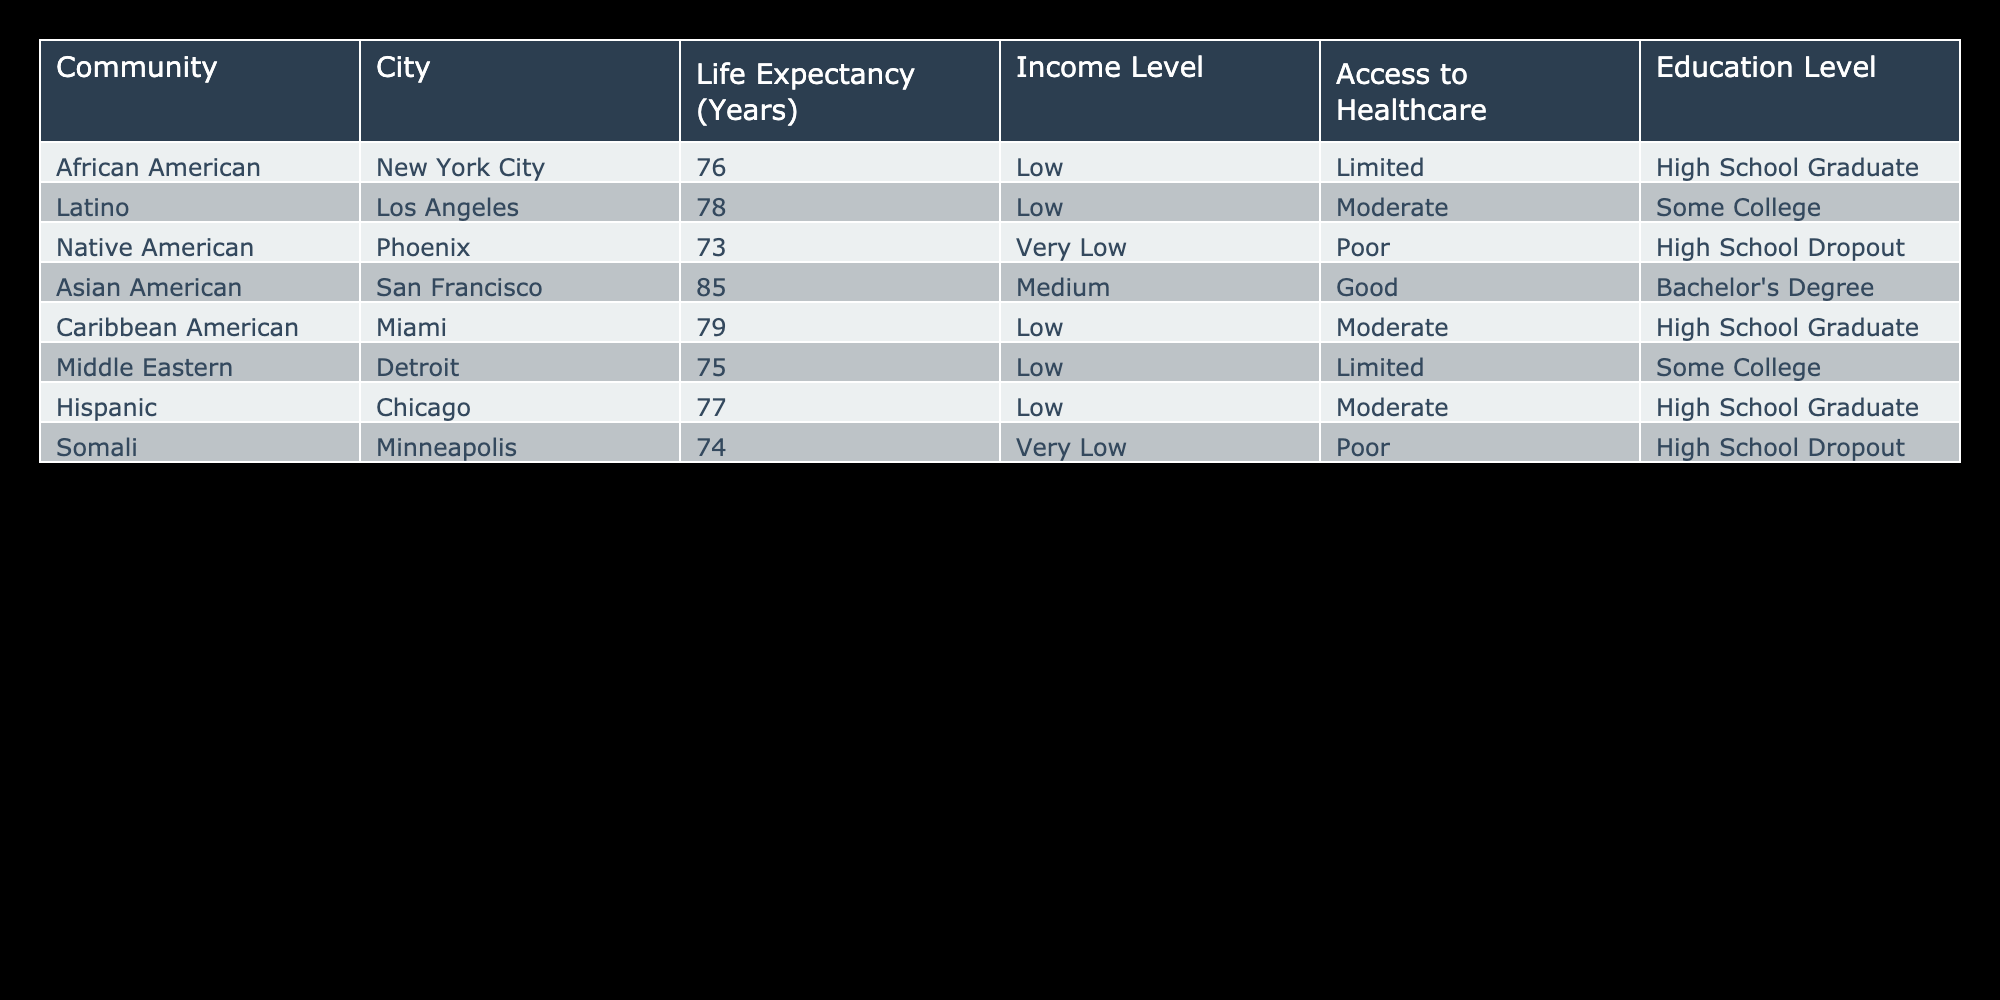What is the life expectancy for Caribbean Americans in Miami? The table shows that the life expectancy for Caribbean Americans in Miami is 79 years.
Answer: 79 Which community has the highest life expectancy? According to the table, Asian Americans in San Francisco have the highest life expectancy at 85 years.
Answer: 85 Is the life expectancy for Native Americans in Phoenix higher than that for Somalis in Minneapolis? The table indicates that Native Americans have a life expectancy of 73 years, while Somalis have a life expectancy of 74 years. Since 74 is greater than 73, the statement is false.
Answer: No What is the average life expectancy of the communities listed? To find the average, sum the life expectancies: 76 + 78 + 73 + 85 + 79 + 75 + 77 + 74 = 618. There are 8 communities, so the average is 618 / 8 = 77.25.
Answer: 77.25 Do all communities listed have a life expectancy above 75 years? If we check the table, Native Americans in Phoenix have a life expectancy of 73 years, which is below 75. Therefore, the answer is no.
Answer: No What is the difference in life expectancy between the highest and lowest community? Asian Americans have the highest life expectancy at 85 years, and Native Americans have the lowest at 73 years. The difference is 85 - 73 = 12 years.
Answer: 12 Are all communities with a "Very Low" income level also having a "Poor" access to healthcare? The table indicates that both Native Americans and Somalis have a "Very Low" income level, but only Somalis have "Poor" access to healthcare while Native Americans have "Poor" access. Thus, the statement is true as both have poor access.
Answer: Yes Which communities have a life expectancy of 78 years or more? From the table, the communities with life expectancy of 78 or more are Asian Americans (85), Latino (78), Caribbean American (79), and Hispanic (77). The last is just under 78, so the eligible communities are the first three.
Answer: Asian American, Latino, Caribbean American What percentage of communities listed have a high school graduate education level? In the table, three communities (African American, Caribbean American, and Hispanic) are high school graduates out of eight total communities. Thus, the percentage is (3 / 8) * 100 = 37.5%.
Answer: 37.5% 